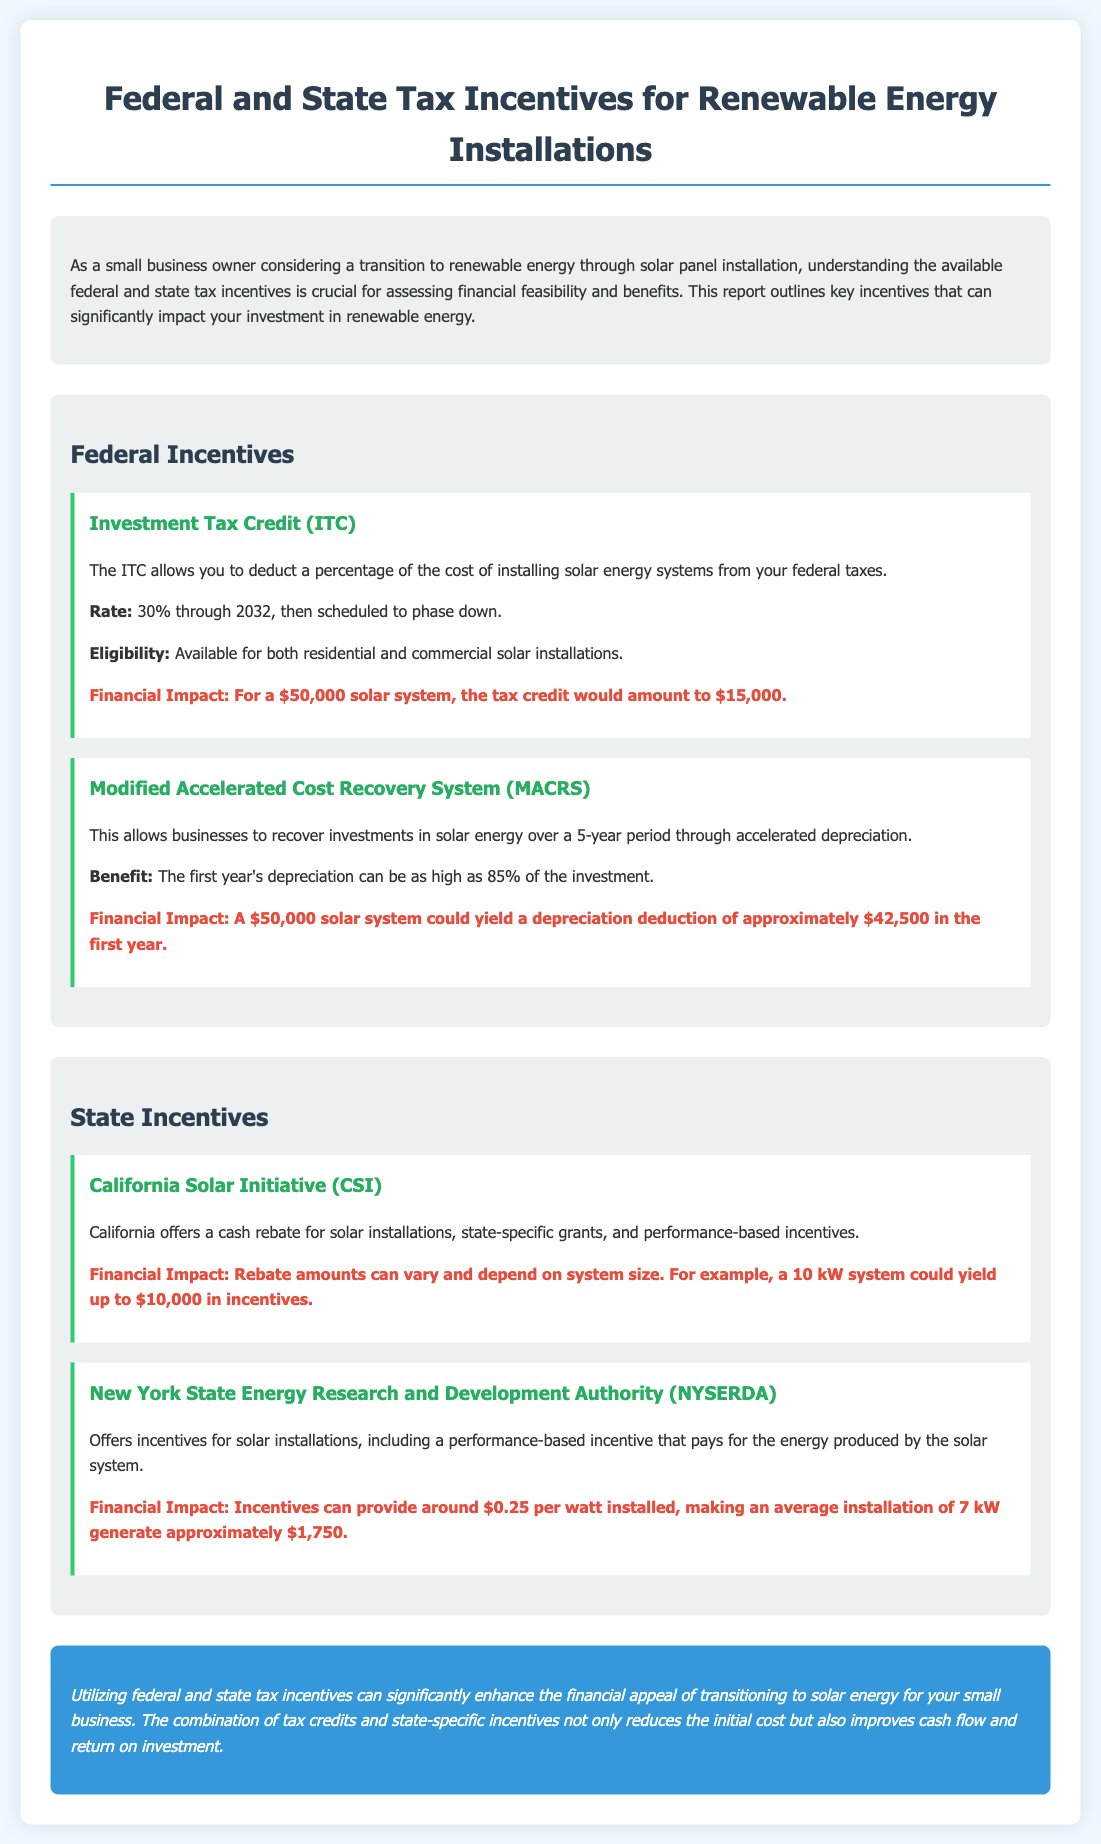What is the federal Investment Tax Credit rate? The document states the ITC allows a deduction of 30% through 2032.
Answer: 30% What is the financial impact of the ITC for a $50,000 solar system? According to the financial impact section, the tax credit would amount to $15,000 for a $50,000 solar system.
Answer: $15,000 What is the benefit of the Modified Accelerated Cost Recovery System? The document explains that it allows businesses to recover investments in solar energy over a 5-year period through accelerated depreciation.
Answer: Accelerated depreciation What financial impact does the California Solar Initiative provide for a 10 kW system? The report indicates that a 10 kW system could yield up to $10,000 in incentives.
Answer: Up to $10,000 What is the performance-based incentive amount offered by NYSERDA per watt installed? The document specifies that NYSERDA incentives can provide around $0.25 per watt installed.
Answer: $0.25 How much can the first year's depreciation deduction be for a $50,000 solar system under MACRS? The financial impact for a $50,000 solar system can yield a depreciation deduction of approximately $42,500 in the first year.
Answer: Approximately $42,500 What kind of incentives does the California Solar Initiative offer? The report mentions cash rebates, state-specific grants, and performance-based incentives.
Answer: Cash rebates, grants, performance-based incentives What is the general conclusion about federal and state tax incentives in the document? The conclusion highlights that these incentives enhance the financial appeal of transitioning to solar energy for small businesses.
Answer: Enhance financial appeal 